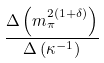Convert formula to latex. <formula><loc_0><loc_0><loc_500><loc_500>\frac { \Delta \left ( m _ { \pi } ^ { 2 ( 1 + \delta ) } \right ) } { \Delta \left ( \kappa ^ { - 1 } \right ) }</formula> 